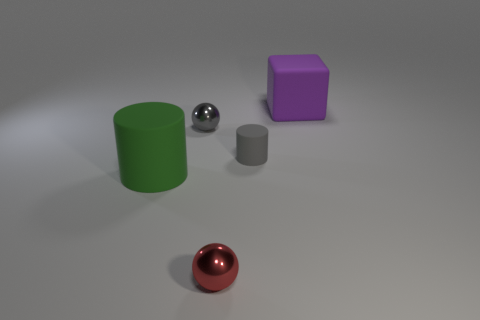Add 4 gray metal spheres. How many objects exist? 9 Subtract all cylinders. How many objects are left? 3 Add 4 small red metallic things. How many small red metallic things are left? 5 Add 2 cubes. How many cubes exist? 3 Subtract 0 green balls. How many objects are left? 5 Subtract all red spheres. Subtract all cyan cubes. How many spheres are left? 1 Subtract all large green shiny cubes. Subtract all small things. How many objects are left? 2 